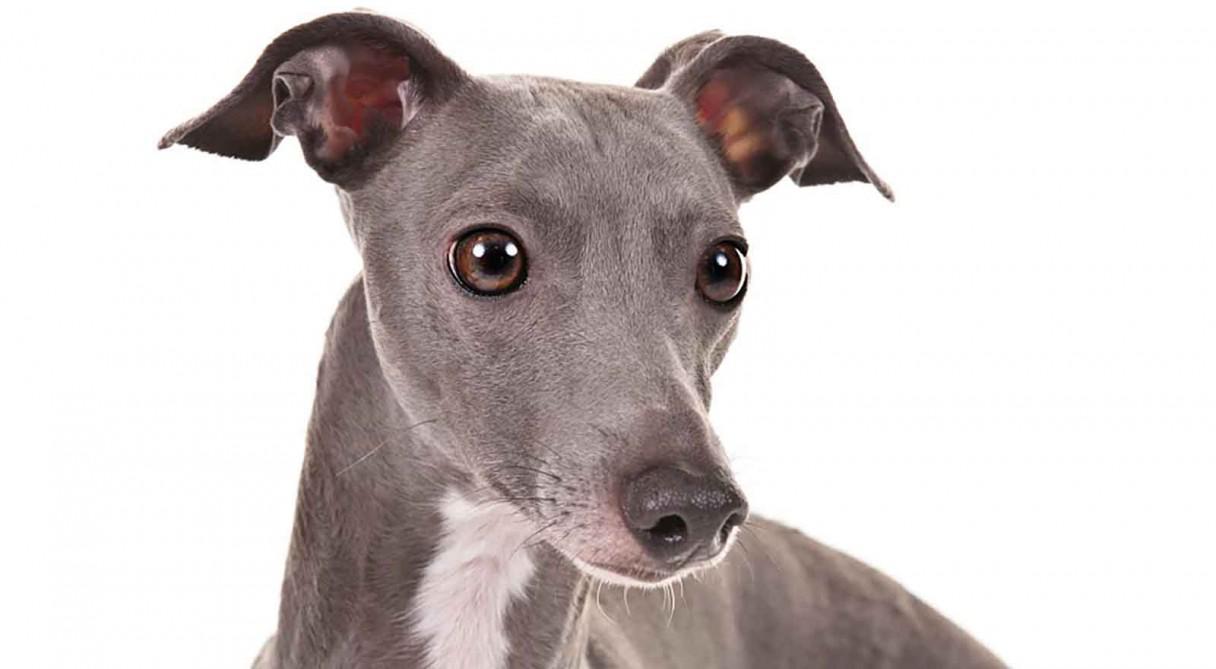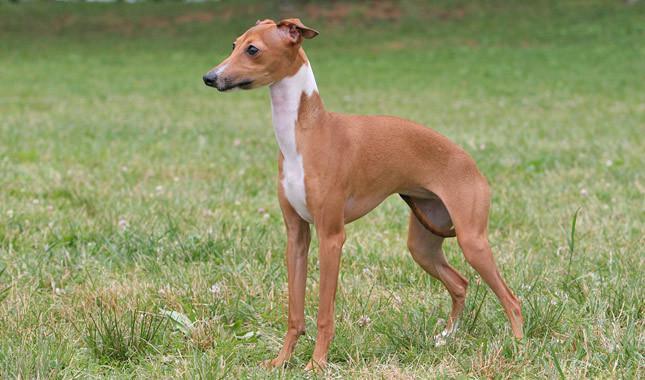The first image is the image on the left, the second image is the image on the right. Considering the images on both sides, is "One image shows a mostly light brown dog standing on all fours in the grass." valid? Answer yes or no. Yes. The first image is the image on the left, the second image is the image on the right. For the images displayed, is the sentence "One of the dogs is resting on a couch." factually correct? Answer yes or no. No. 